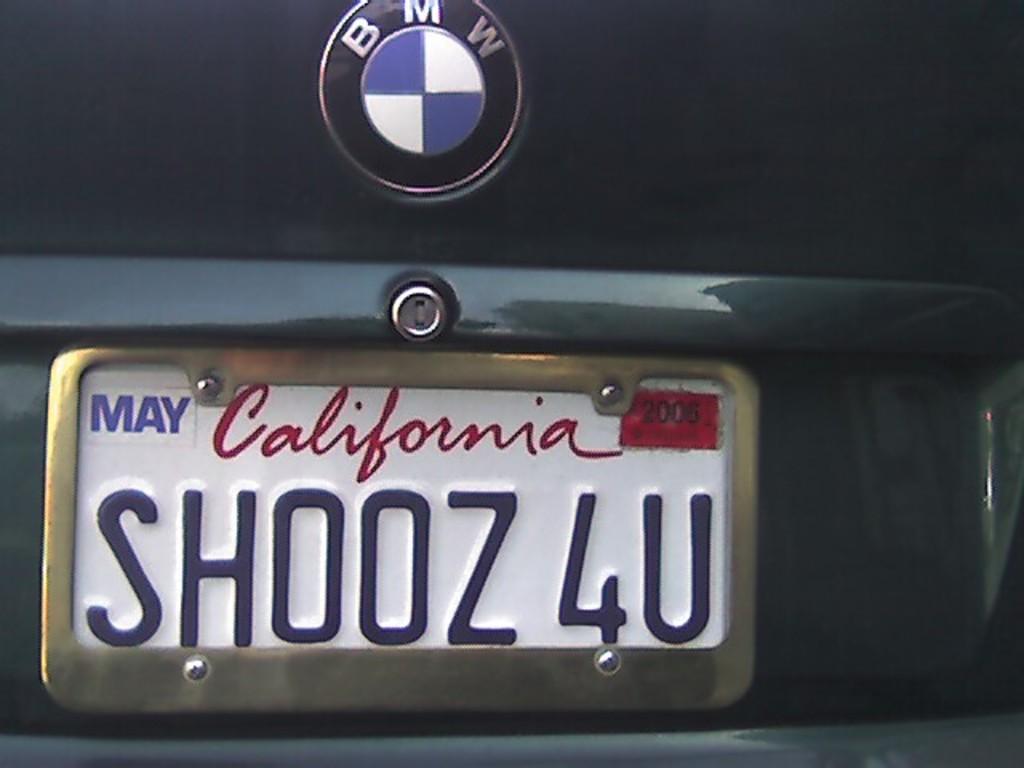What state is the license plate from?
Give a very brief answer. California. What month was the plate issued?
Ensure brevity in your answer.  May. 